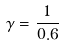<formula> <loc_0><loc_0><loc_500><loc_500>\gamma = \frac { 1 } { 0 . 6 }</formula> 